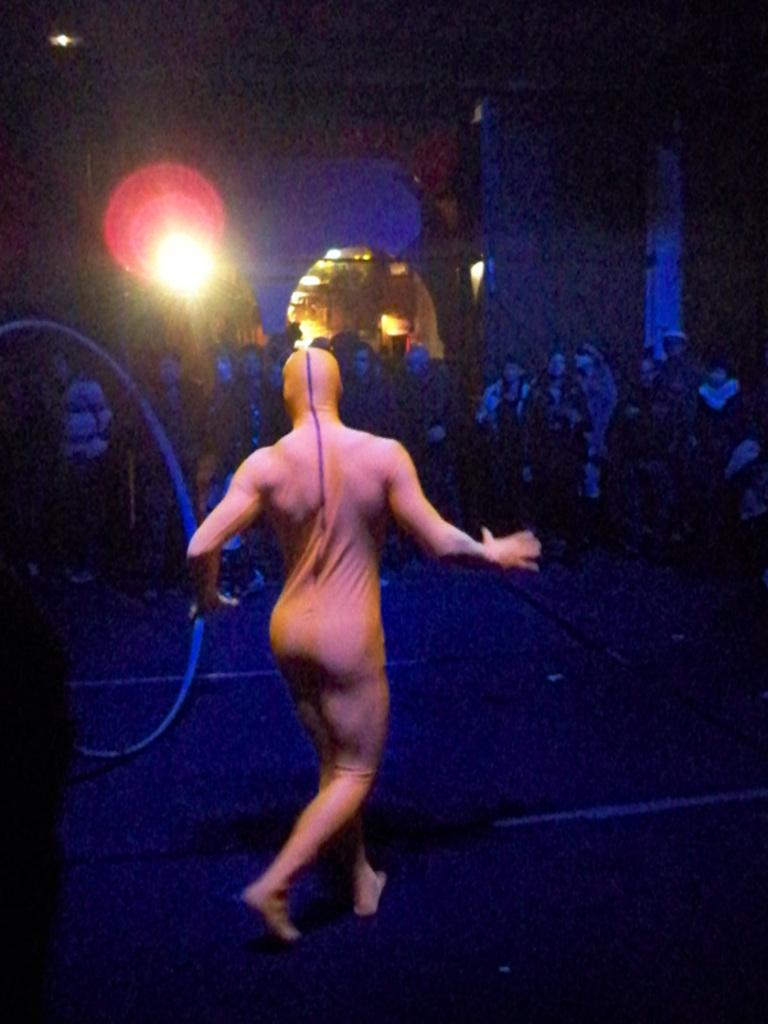What is the main subject of the image? There is a person performing on the floor in the image. Can you describe the setting of the image? There are persons visible in the background of the image, and there is light in the background as well. How many frames are present in the image? The image is a single photograph and does not have frames. 